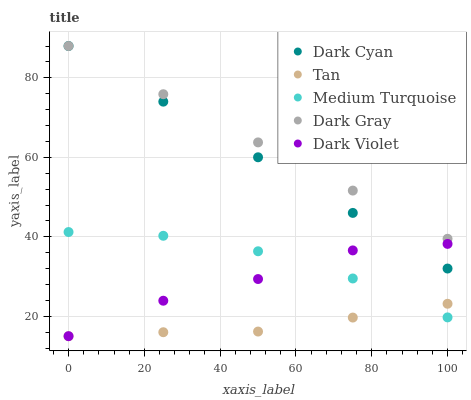Does Tan have the minimum area under the curve?
Answer yes or no. Yes. Does Dark Gray have the maximum area under the curve?
Answer yes or no. Yes. Does Dark Gray have the minimum area under the curve?
Answer yes or no. No. Does Tan have the maximum area under the curve?
Answer yes or no. No. Is Dark Gray the smoothest?
Answer yes or no. Yes. Is Dark Violet the roughest?
Answer yes or no. Yes. Is Tan the smoothest?
Answer yes or no. No. Is Tan the roughest?
Answer yes or no. No. Does Tan have the lowest value?
Answer yes or no. Yes. Does Dark Gray have the lowest value?
Answer yes or no. No. Does Dark Gray have the highest value?
Answer yes or no. Yes. Does Tan have the highest value?
Answer yes or no. No. Is Tan less than Dark Gray?
Answer yes or no. Yes. Is Dark Gray greater than Tan?
Answer yes or no. Yes. Does Dark Cyan intersect Dark Gray?
Answer yes or no. Yes. Is Dark Cyan less than Dark Gray?
Answer yes or no. No. Is Dark Cyan greater than Dark Gray?
Answer yes or no. No. Does Tan intersect Dark Gray?
Answer yes or no. No. 